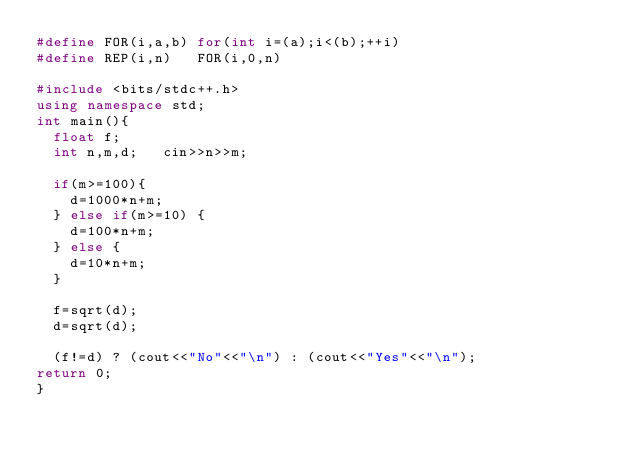<code> <loc_0><loc_0><loc_500><loc_500><_C++_>#define FOR(i,a,b) for(int i=(a);i<(b);++i)
#define REP(i,n)   FOR(i,0,n)

#include <bits/stdc++.h>
using namespace std;
int main(){
  float f;
  int n,m,d;   cin>>n>>m;
  
  if(m>=100){
    d=1000*n+m;
  } else if(m>=10) {
    d=100*n+m;
  } else {
    d=10*n+m;
  }
  
  f=sqrt(d);
  d=sqrt(d);
  
  (f!=d) ? (cout<<"No"<<"\n") : (cout<<"Yes"<<"\n");
return 0;
}</code> 